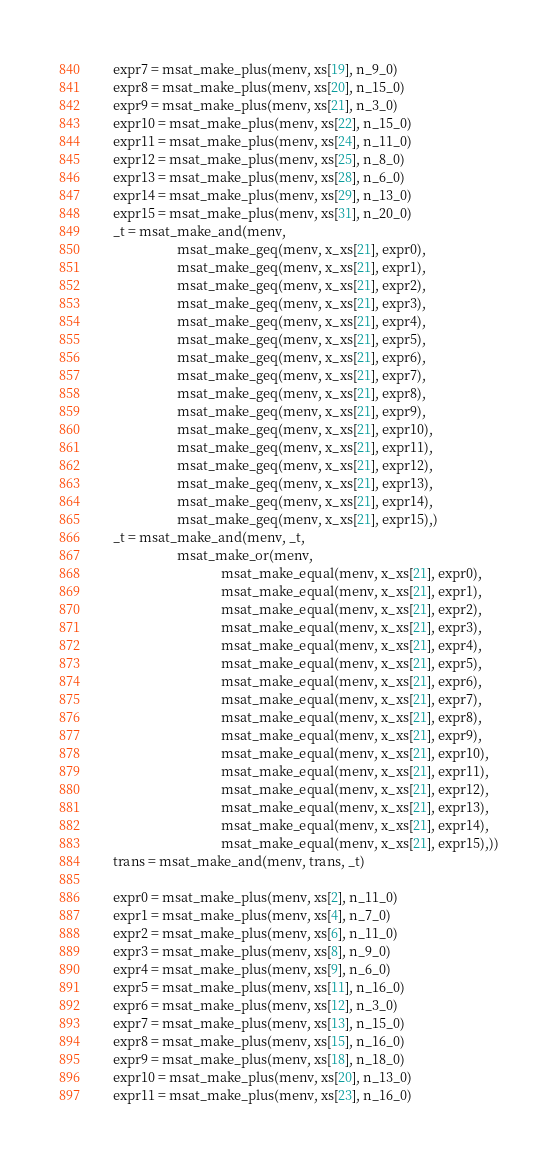Convert code to text. <code><loc_0><loc_0><loc_500><loc_500><_Python_>    expr7 = msat_make_plus(menv, xs[19], n_9_0)
    expr8 = msat_make_plus(menv, xs[20], n_15_0)
    expr9 = msat_make_plus(menv, xs[21], n_3_0)
    expr10 = msat_make_plus(menv, xs[22], n_15_0)
    expr11 = msat_make_plus(menv, xs[24], n_11_0)
    expr12 = msat_make_plus(menv, xs[25], n_8_0)
    expr13 = msat_make_plus(menv, xs[28], n_6_0)
    expr14 = msat_make_plus(menv, xs[29], n_13_0)
    expr15 = msat_make_plus(menv, xs[31], n_20_0)
    _t = msat_make_and(menv,
                       msat_make_geq(menv, x_xs[21], expr0),
                       msat_make_geq(menv, x_xs[21], expr1),
                       msat_make_geq(menv, x_xs[21], expr2),
                       msat_make_geq(menv, x_xs[21], expr3),
                       msat_make_geq(menv, x_xs[21], expr4),
                       msat_make_geq(menv, x_xs[21], expr5),
                       msat_make_geq(menv, x_xs[21], expr6),
                       msat_make_geq(menv, x_xs[21], expr7),
                       msat_make_geq(menv, x_xs[21], expr8),
                       msat_make_geq(menv, x_xs[21], expr9),
                       msat_make_geq(menv, x_xs[21], expr10),
                       msat_make_geq(menv, x_xs[21], expr11),
                       msat_make_geq(menv, x_xs[21], expr12),
                       msat_make_geq(menv, x_xs[21], expr13),
                       msat_make_geq(menv, x_xs[21], expr14),
                       msat_make_geq(menv, x_xs[21], expr15),)
    _t = msat_make_and(menv, _t,
                       msat_make_or(menv,
                                    msat_make_equal(menv, x_xs[21], expr0),
                                    msat_make_equal(menv, x_xs[21], expr1),
                                    msat_make_equal(menv, x_xs[21], expr2),
                                    msat_make_equal(menv, x_xs[21], expr3),
                                    msat_make_equal(menv, x_xs[21], expr4),
                                    msat_make_equal(menv, x_xs[21], expr5),
                                    msat_make_equal(menv, x_xs[21], expr6),
                                    msat_make_equal(menv, x_xs[21], expr7),
                                    msat_make_equal(menv, x_xs[21], expr8),
                                    msat_make_equal(menv, x_xs[21], expr9),
                                    msat_make_equal(menv, x_xs[21], expr10),
                                    msat_make_equal(menv, x_xs[21], expr11),
                                    msat_make_equal(menv, x_xs[21], expr12),
                                    msat_make_equal(menv, x_xs[21], expr13),
                                    msat_make_equal(menv, x_xs[21], expr14),
                                    msat_make_equal(menv, x_xs[21], expr15),))
    trans = msat_make_and(menv, trans, _t)

    expr0 = msat_make_plus(menv, xs[2], n_11_0)
    expr1 = msat_make_plus(menv, xs[4], n_7_0)
    expr2 = msat_make_plus(menv, xs[6], n_11_0)
    expr3 = msat_make_plus(menv, xs[8], n_9_0)
    expr4 = msat_make_plus(menv, xs[9], n_6_0)
    expr5 = msat_make_plus(menv, xs[11], n_16_0)
    expr6 = msat_make_plus(menv, xs[12], n_3_0)
    expr7 = msat_make_plus(menv, xs[13], n_15_0)
    expr8 = msat_make_plus(menv, xs[15], n_16_0)
    expr9 = msat_make_plus(menv, xs[18], n_18_0)
    expr10 = msat_make_plus(menv, xs[20], n_13_0)
    expr11 = msat_make_plus(menv, xs[23], n_16_0)</code> 